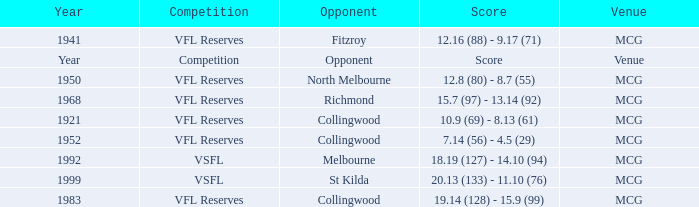At what venue was there a competition with a score reported as 7.14 (56) - 4.5 (29)? MCG. 